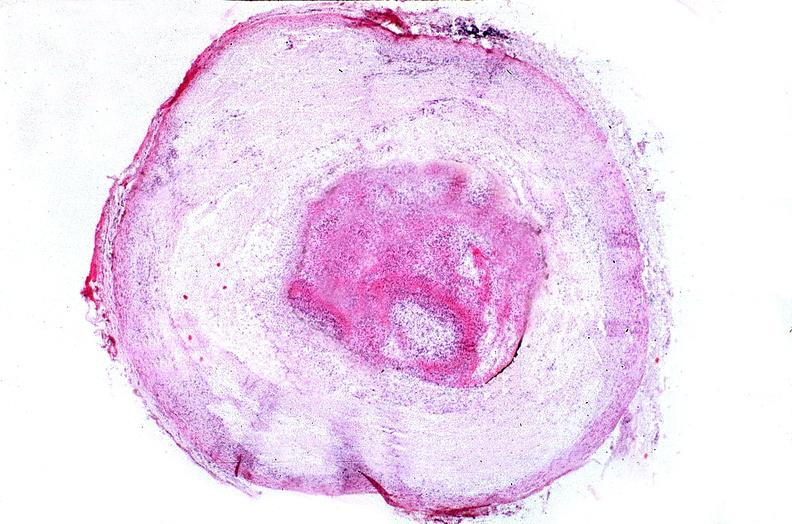what is present?
Answer the question using a single word or phrase. Cardiovascular 